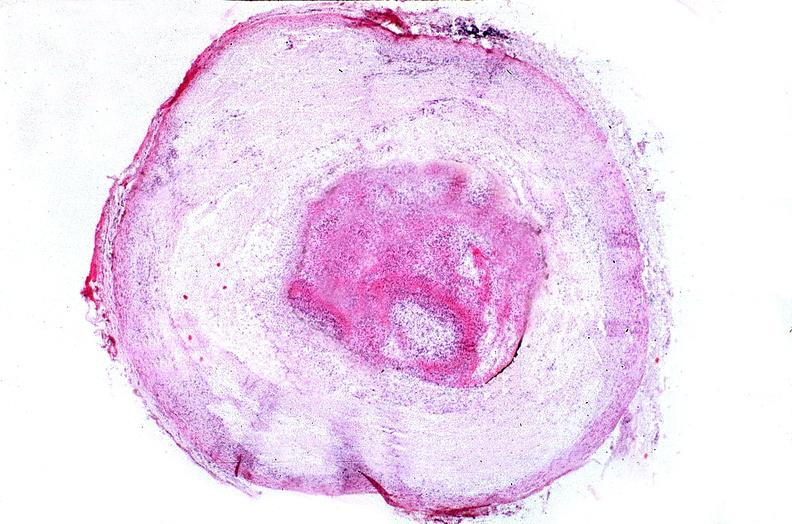what is present?
Answer the question using a single word or phrase. Cardiovascular 